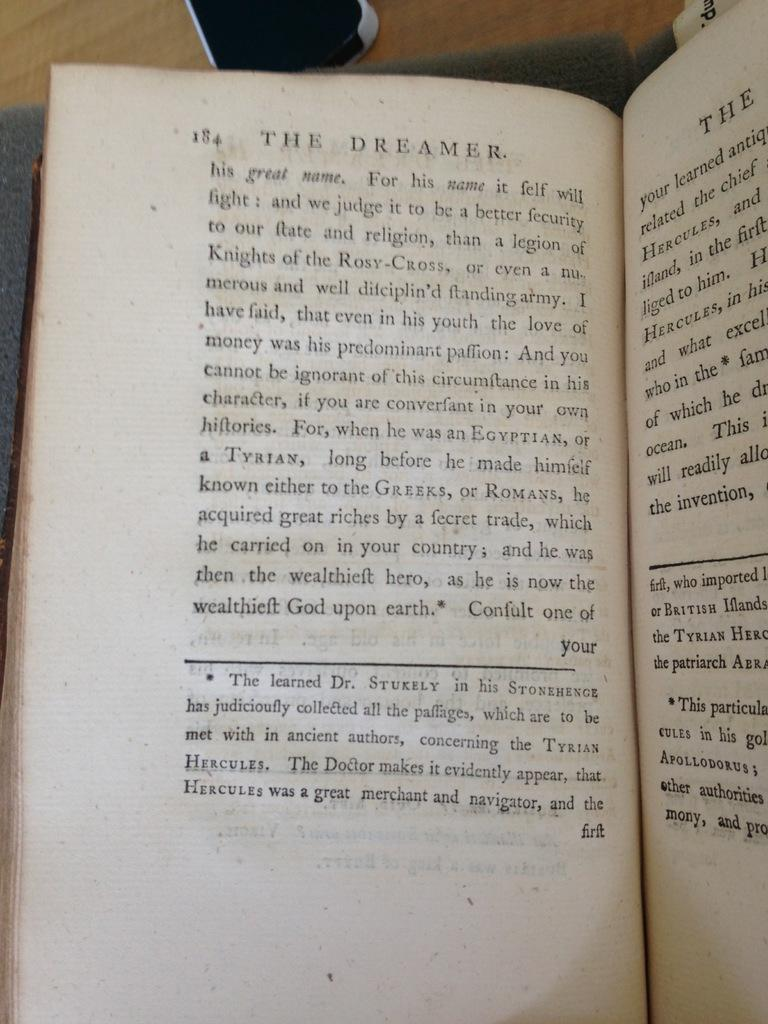<image>
Provide a brief description of the given image. The Dreamer novel that is opened to page 184. 